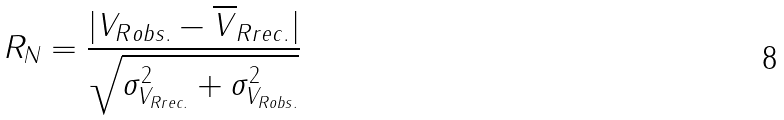Convert formula to latex. <formula><loc_0><loc_0><loc_500><loc_500>R _ { N } = \frac { | V _ { R o b s . } - \overline { V } _ { R r e c . } | } { \sqrt { \sigma _ { V _ { R r e c . } } ^ { 2 } + \sigma _ { V _ { R o b s . } } ^ { 2 } } }</formula> 